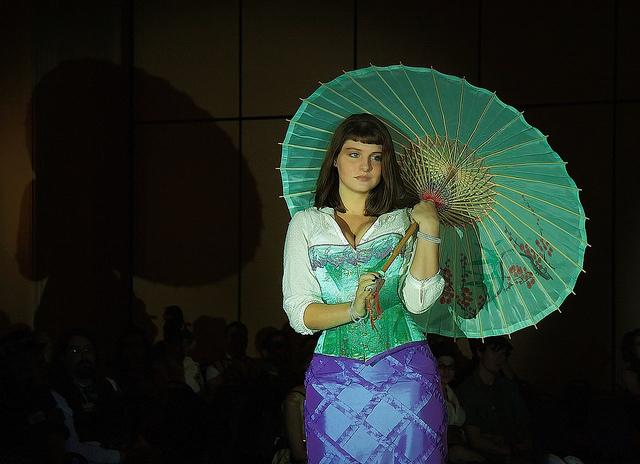What type of umbrella is she holding?
Give a very brief answer. Chinese. What color is her skirt?
Write a very short answer. Purple. What color is the girl's skirt?
Be succinct. Purple. How old is the woman in the photo?
Give a very brief answer. 20. Why does she need an umbrella indoors?
Give a very brief answer. Fashion. 